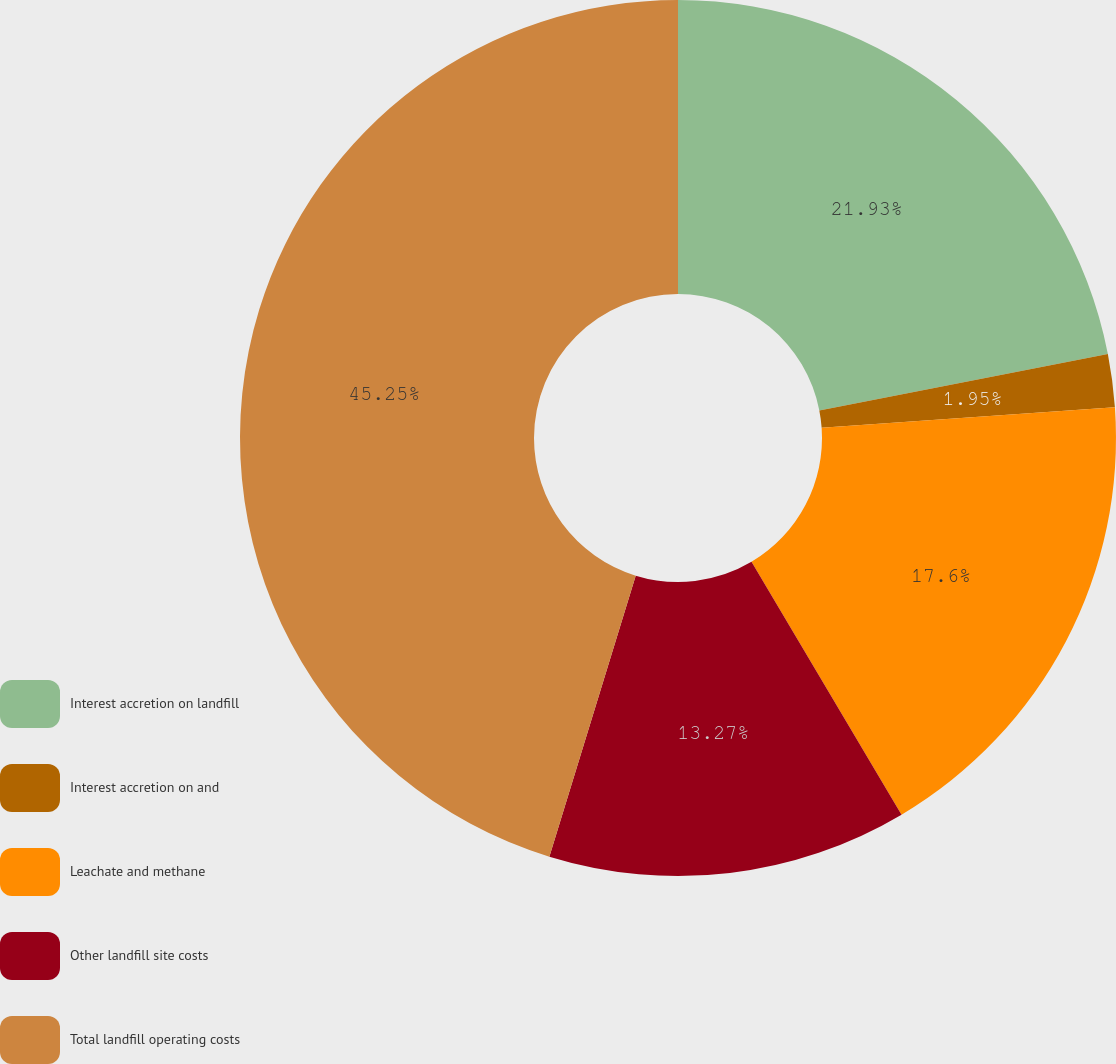Convert chart to OTSL. <chart><loc_0><loc_0><loc_500><loc_500><pie_chart><fcel>Interest accretion on landfill<fcel>Interest accretion on and<fcel>Leachate and methane<fcel>Other landfill site costs<fcel>Total landfill operating costs<nl><fcel>21.93%<fcel>1.95%<fcel>17.6%<fcel>13.27%<fcel>45.26%<nl></chart> 